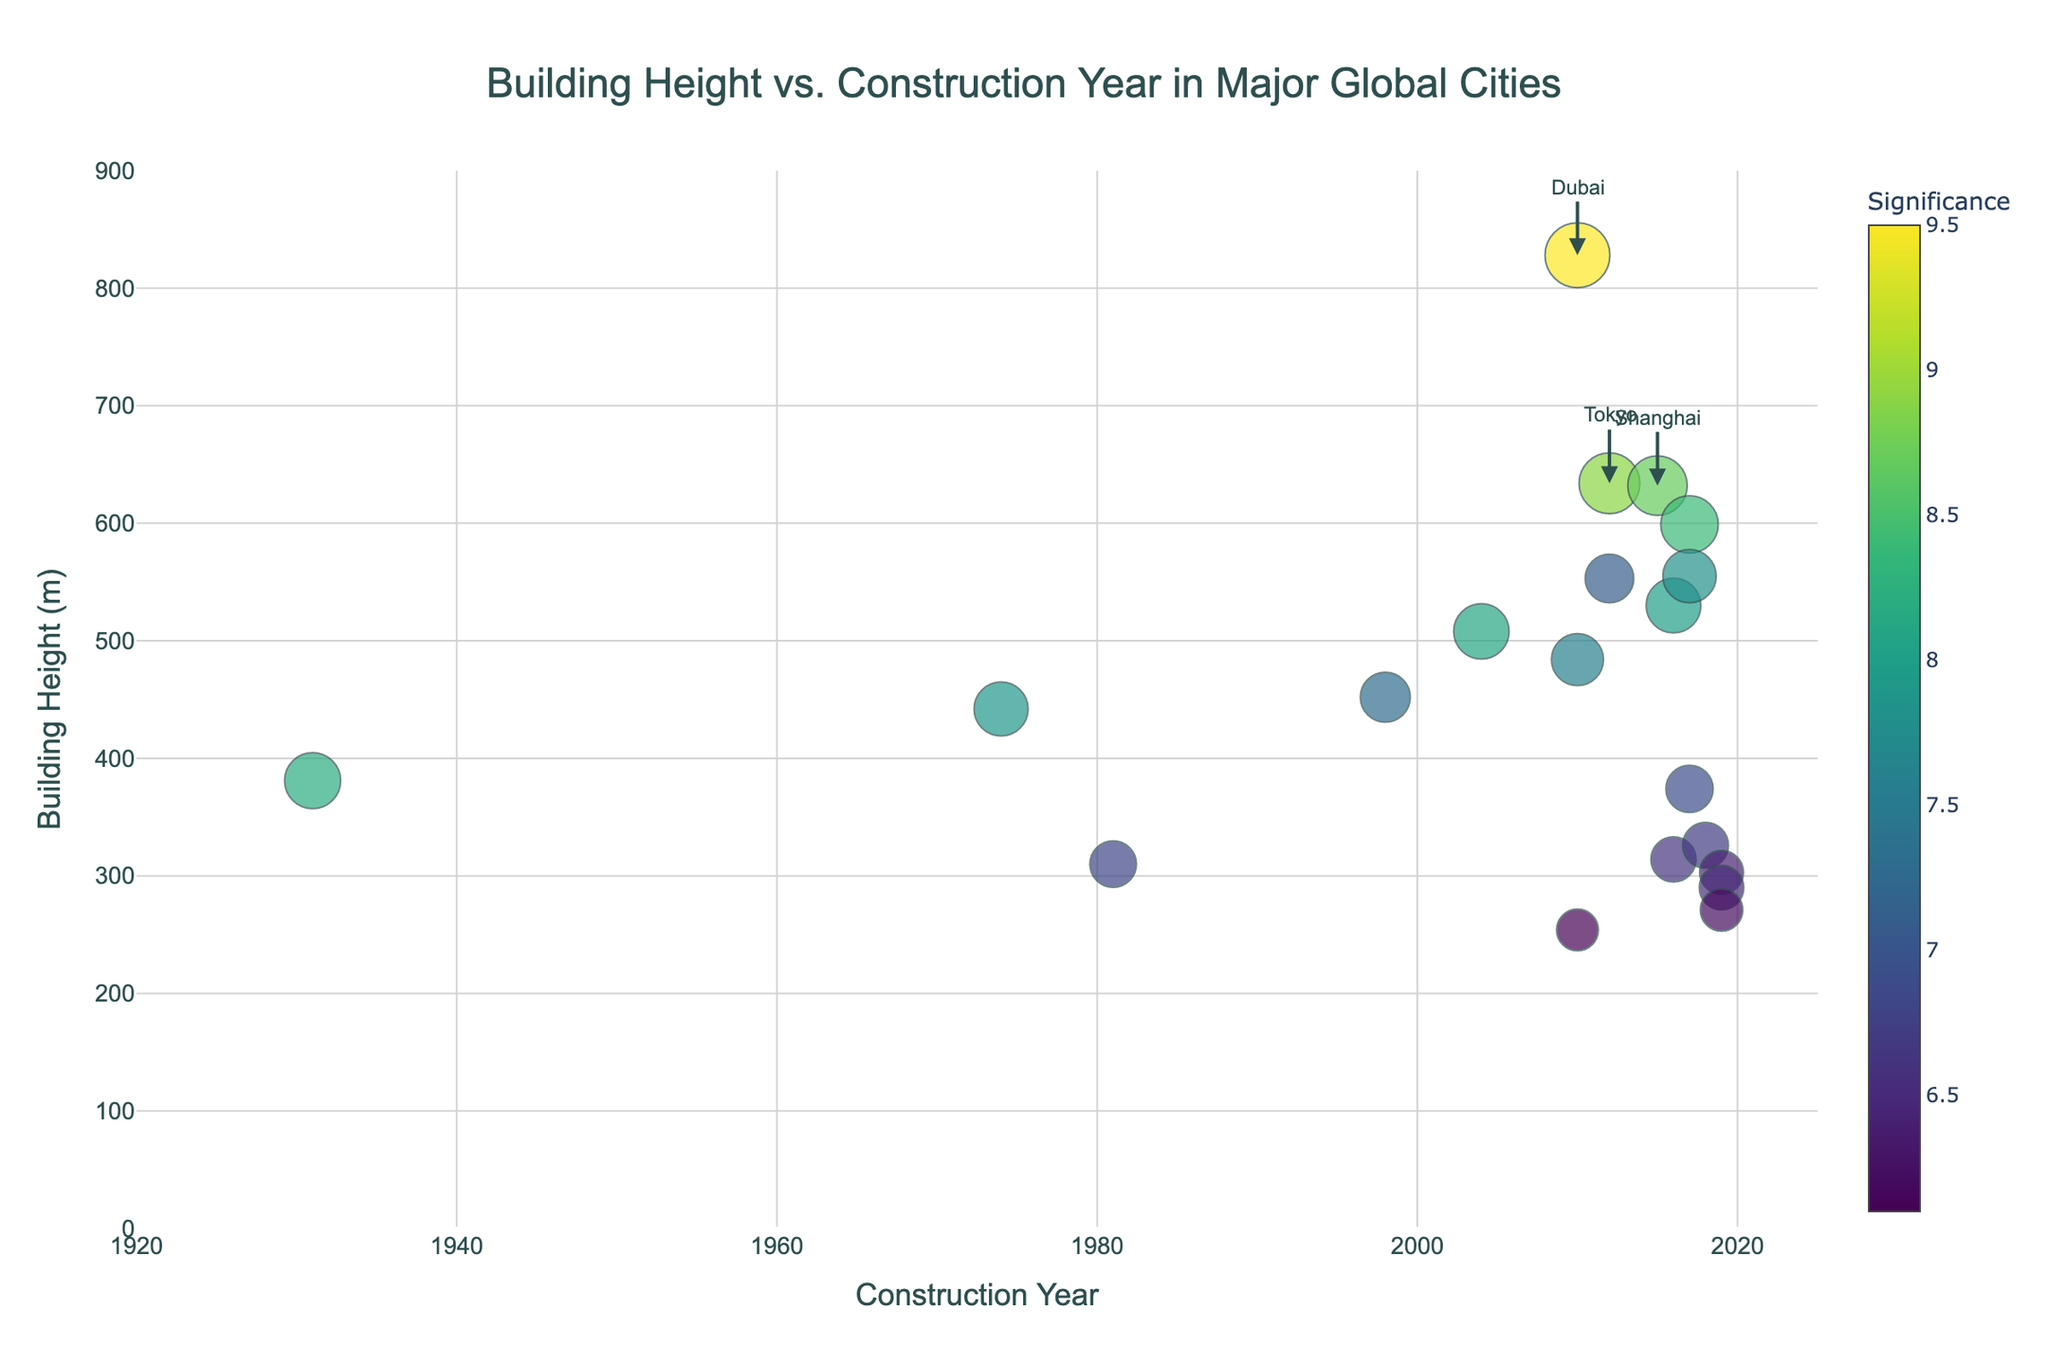What is the title of the plot? The title is written at the top center of the plot. It is clearly visible and indicates the main theme of the plot.
Answer: Building Height vs. Construction Year in Major Global Cities Which city has the tallest building in this plot? The tallest building corresponds to the highest point on the y-axis. From the plot, we see that the tallest building is located in Dubai.
Answer: Dubai What is the range of the construction years shown on the x-axis? The x-axis represents the construction years, with labels indicating the range. From the plot, it starts at 1920 and extends to 2025.
Answer: 1920 to 2025 Which cities have buildings with a significance greater than 8.5? Buildings with significance greater than 8.5 have larger colored markers, and likely annotated. From the plot, these cities are Dubai, Shanghai, and Tokyo.
Answer: Dubai, Shanghai, and Tokyo What is the building height of the oldest building in the plot? The oldest building would be the leftmost point on the x-axis. From the plot, the oldest building is located in New York with a height of 381 meters.
Answer: 381 meters How does the significance color scale vary in the plot? The significance is represented by the color of the markers. The color scale ranges from light to dark in the 'Viridis' colors. Higher significance values are darker.
Answer: The colors range from light to dark, with higher significance being darker Which two cities have buildings constructed in 2012, and what are their heights? Locate the data points along the vertical line corresponding to the year 2012. The cities are Toronto and Tokyo, with heights of 553 meters and 634 meters respectively.
Answer: Toronto (553 meters) and Tokyo (634 meters) Between Kuala Lumpur and Taipei, which city has a taller building, and by how much? Compare the heights of the buildings for Kuala Lumpur (452 meters) and Taipei (508 meters). To find the difference, subtract the height of Kuala Lumpur from Taipei.
Answer: Taipei is taller by 56 meters What pattern do you observe in the relationship between building height and construction year? Observe the general trend of the data points. Buildings appear to increase in height over time, suggesting a positive correlation.
Answer: Heights generally increase over time, showing a positive trend How many buildings constructed after 2010 have a height over 500 meters? Look for data points to the right of 2010 on the x-axis and above 500 meters on the y-axis. There are four such buildings, in Shenzhen, Seoul, Guangzhou, and Shanghai.
Answer: Four 